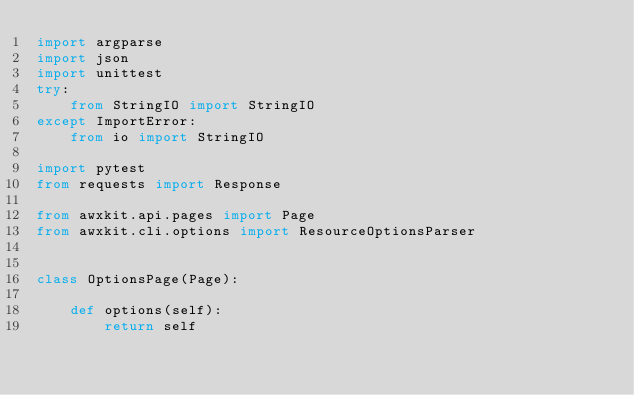<code> <loc_0><loc_0><loc_500><loc_500><_Python_>import argparse
import json
import unittest
try:
    from StringIO import StringIO
except ImportError:
    from io import StringIO

import pytest
from requests import Response

from awxkit.api.pages import Page
from awxkit.cli.options import ResourceOptionsParser


class OptionsPage(Page):

    def options(self):
        return self
</code> 